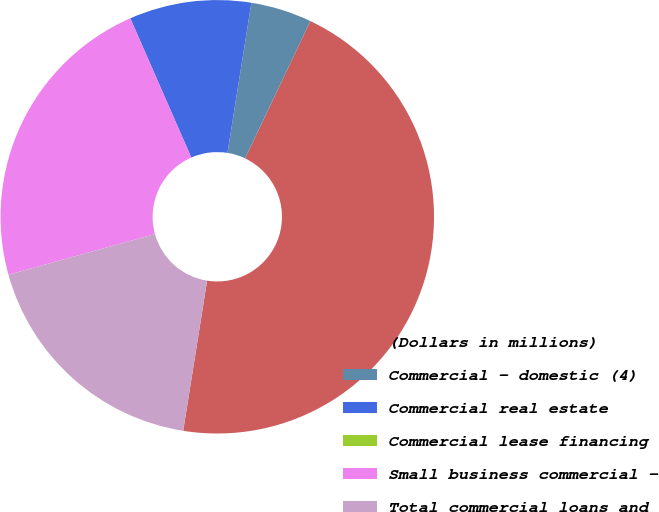<chart> <loc_0><loc_0><loc_500><loc_500><pie_chart><fcel>(Dollars in millions)<fcel>Commercial - domestic (4)<fcel>Commercial real estate<fcel>Commercial lease financing<fcel>Small business commercial -<fcel>Total commercial loans and<nl><fcel>45.45%<fcel>4.55%<fcel>9.09%<fcel>0.0%<fcel>22.73%<fcel>18.18%<nl></chart> 